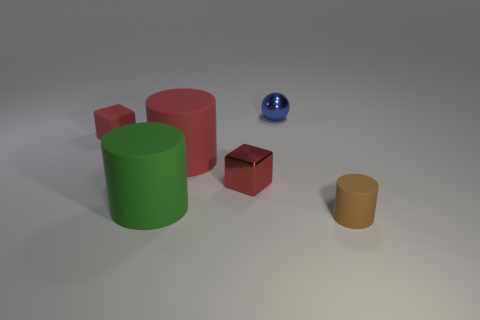Add 2 purple matte cylinders. How many objects exist? 8 Subtract all blocks. How many objects are left? 4 Add 6 large blue shiny things. How many large blue shiny things exist? 6 Subtract 0 gray balls. How many objects are left? 6 Subtract all small blocks. Subtract all tiny matte objects. How many objects are left? 2 Add 5 blue balls. How many blue balls are left? 6 